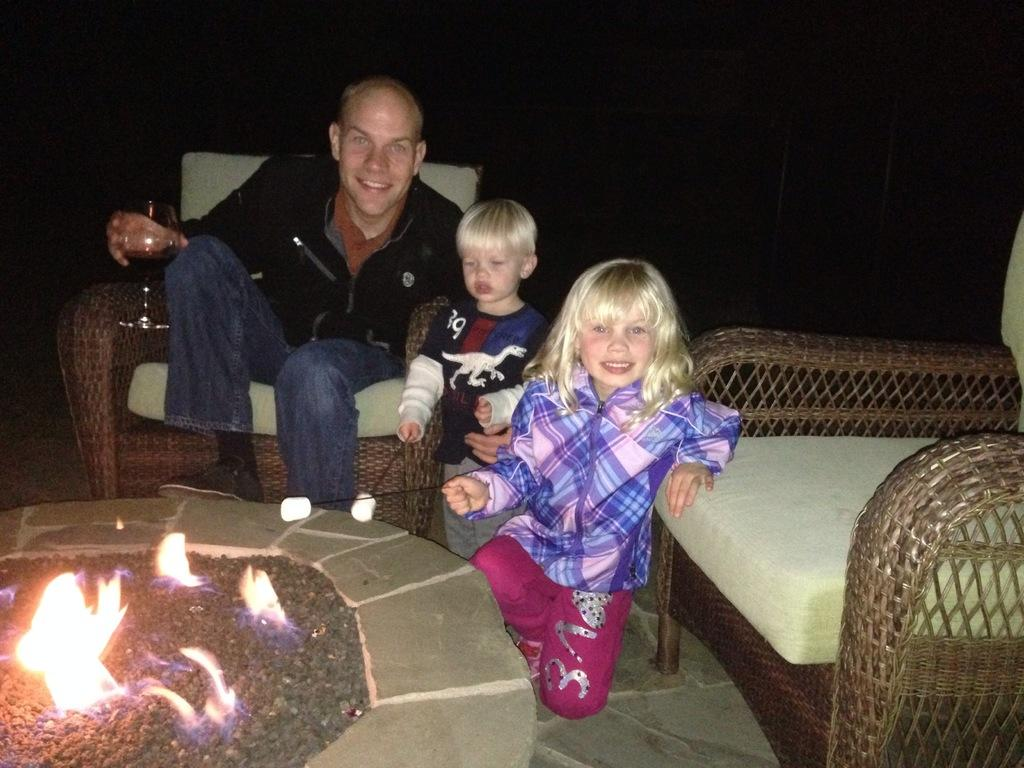What is happening in the image involving a group of people? There is a group of people in the image, and they are sitting on chairs. What are the people holding in the image? The people are holding wine glasses in the image. Can you describe the seating arrangement in the image? There is at least one chair in the image, and the people are sitting on it. What is the presence of fire in the image indicative of? The fire in the image suggests that there might be a source of heat or a gathering around a fire. What type of cannon is present in the image? There is no cannon present in the image. In which hall is the gathering of people taking place in the image? The image does not specify a hall or any specific location for the gathering of people. 